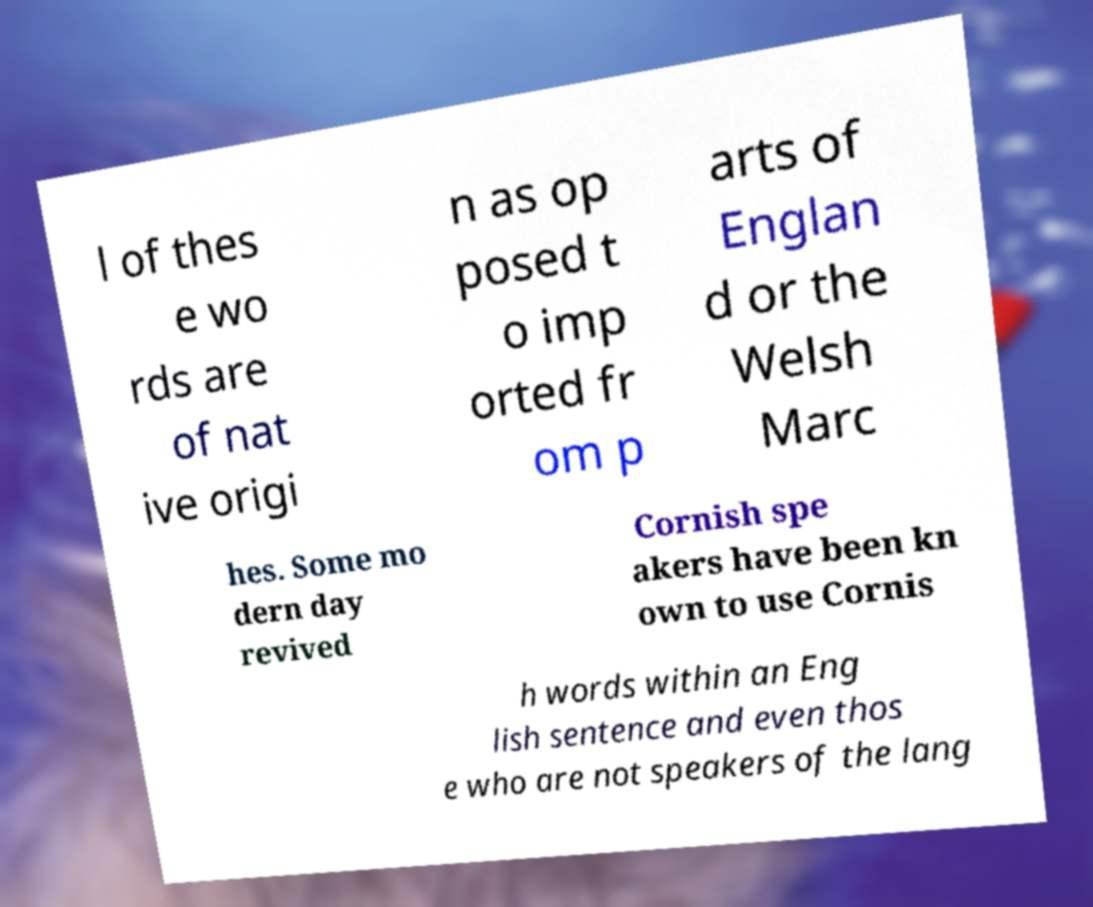Can you read and provide the text displayed in the image?This photo seems to have some interesting text. Can you extract and type it out for me? l of thes e wo rds are of nat ive origi n as op posed t o imp orted fr om p arts of Englan d or the Welsh Marc hes. Some mo dern day revived Cornish spe akers have been kn own to use Cornis h words within an Eng lish sentence and even thos e who are not speakers of the lang 